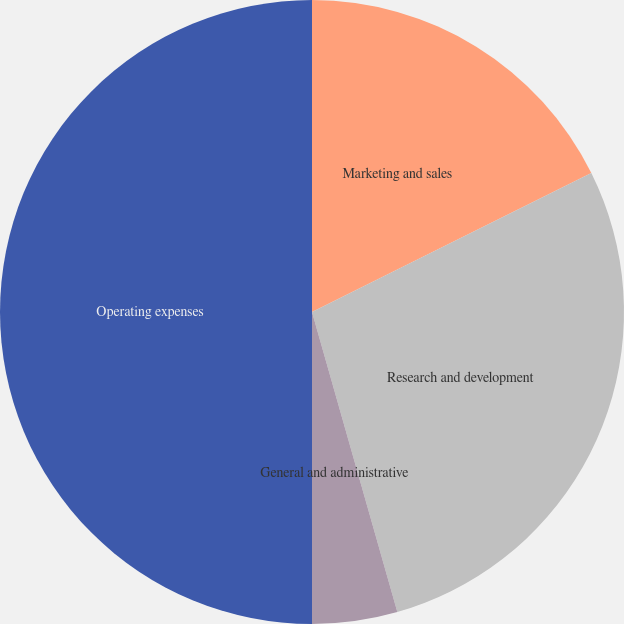Convert chart to OTSL. <chart><loc_0><loc_0><loc_500><loc_500><pie_chart><fcel>Marketing and sales<fcel>Research and development<fcel>General and administrative<fcel>Operating expenses<nl><fcel>17.65%<fcel>27.94%<fcel>4.41%<fcel>50.0%<nl></chart> 